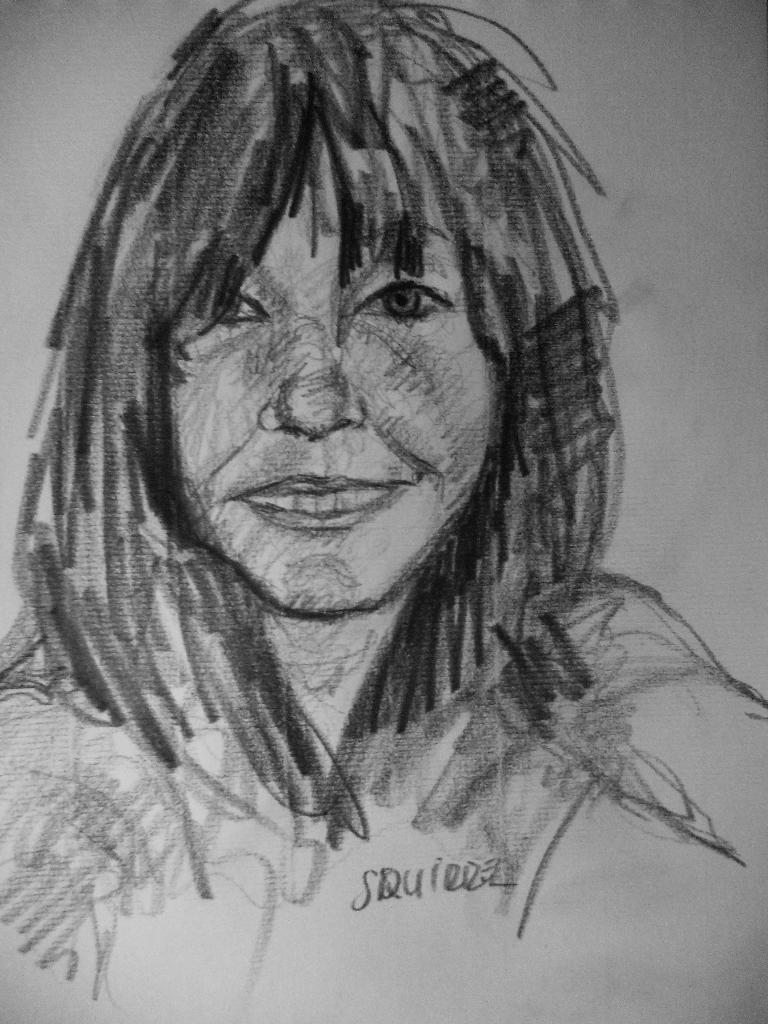Please provide a concise description of this image. In this image we can see the sketch of a person. 